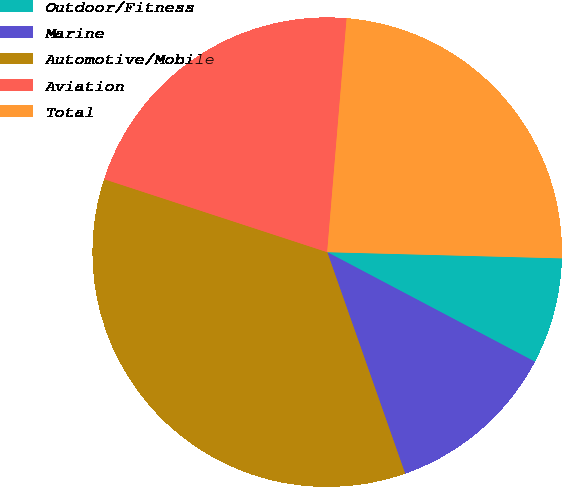Convert chart to OTSL. <chart><loc_0><loc_0><loc_500><loc_500><pie_chart><fcel>Outdoor/Fitness<fcel>Marine<fcel>Automotive/Mobile<fcel>Aviation<fcel>Total<nl><fcel>7.31%<fcel>11.89%<fcel>35.42%<fcel>21.29%<fcel>24.1%<nl></chart> 